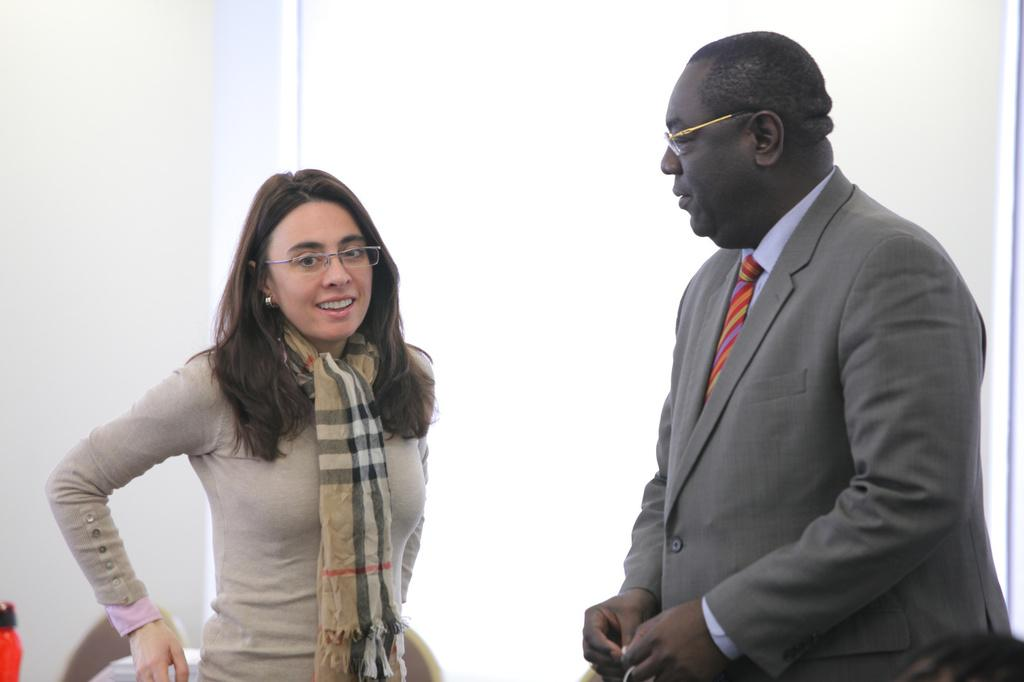Who is the main subject in the image? There is a lady in the center of the image. What is the lady wearing in the image? The lady is wearing a jacket and has a scarf around her neck. Can you describe the person beside the lady? The person beside the lady is wearing a grey color suit. What type of store can be seen in the background of the image? There is no store visible in the image; it only features the lady and the person beside her. 